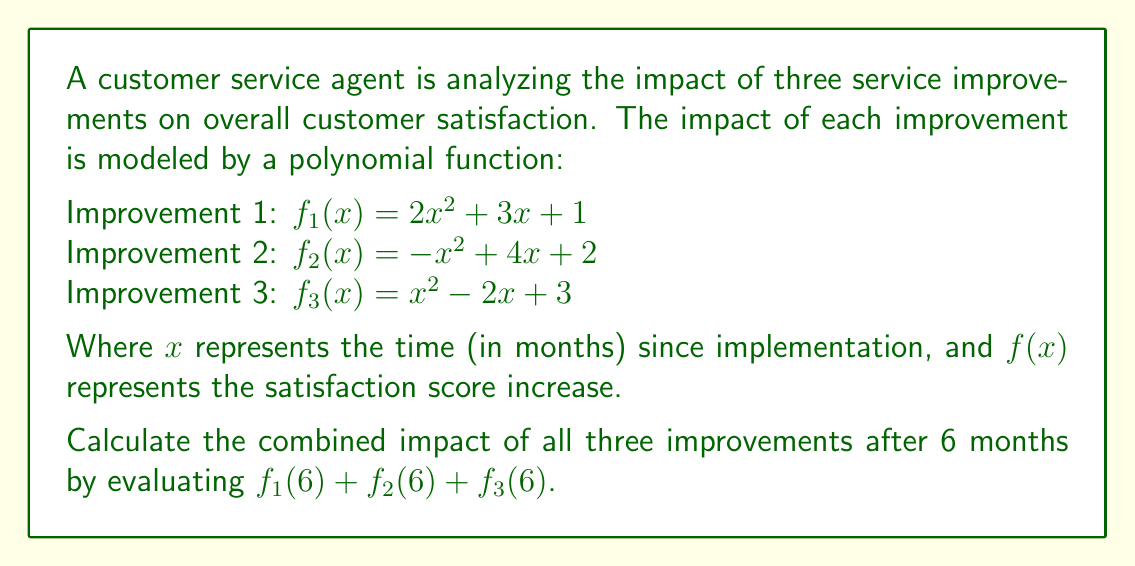Teach me how to tackle this problem. To solve this problem, we need to evaluate each polynomial function at $x = 6$ and then sum the results. Let's break it down step by step:

1. Evaluate $f_1(6)$:
   $f_1(6) = 2(6)^2 + 3(6) + 1$
   $= 2(36) + 18 + 1$
   $= 72 + 18 + 1$
   $= 91$

2. Evaluate $f_2(6)$:
   $f_2(6) = -(6)^2 + 4(6) + 2$
   $= -36 + 24 + 2$
   $= -10$

3. Evaluate $f_3(6)$:
   $f_3(6) = (6)^2 - 2(6) + 3$
   $= 36 - 12 + 3$
   $= 27$

4. Sum the results:
   $f_1(6) + f_2(6) + f_3(6) = 91 + (-10) + 27 = 108$

Therefore, the combined impact of all three improvements after 6 months is an increase of 108 points in the satisfaction score.
Answer: 108 